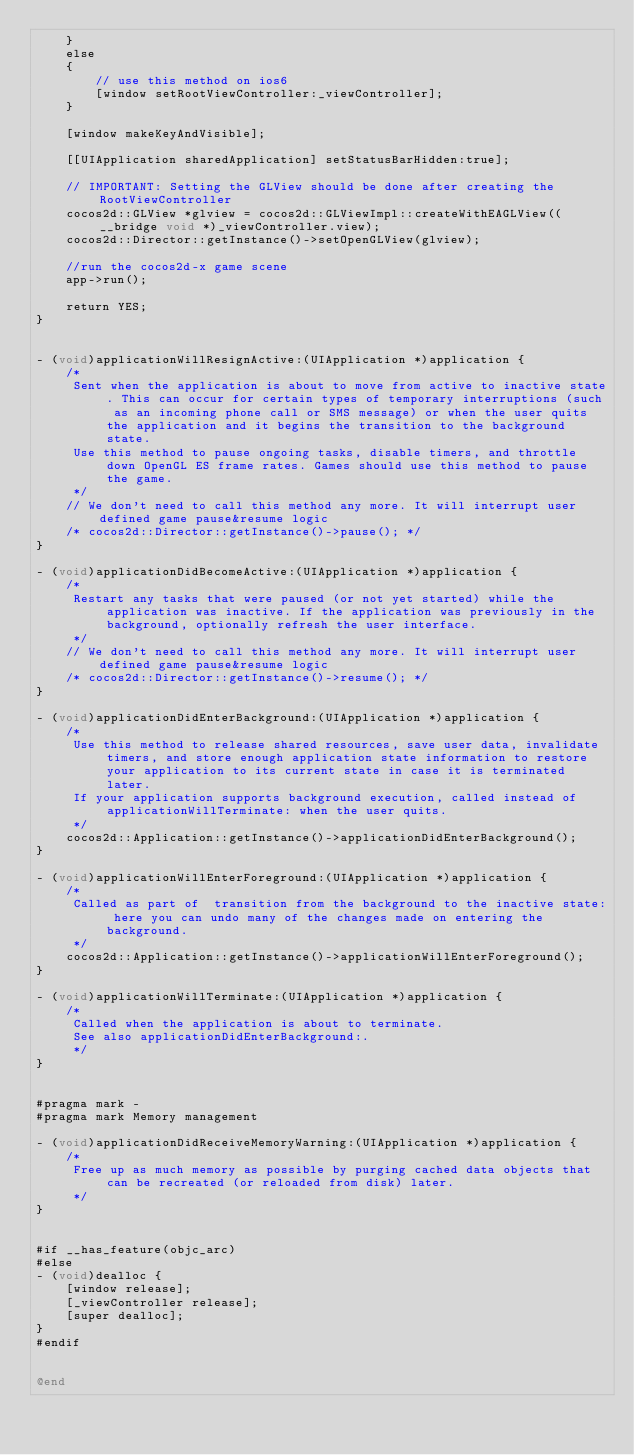<code> <loc_0><loc_0><loc_500><loc_500><_ObjectiveC_>    }
    else
    {
        // use this method on ios6
        [window setRootViewController:_viewController];
    }
    
    [window makeKeyAndVisible];
    
    [[UIApplication sharedApplication] setStatusBarHidden:true];
    
    // IMPORTANT: Setting the GLView should be done after creating the RootViewController
    cocos2d::GLView *glview = cocos2d::GLViewImpl::createWithEAGLView((__bridge void *)_viewController.view);
    cocos2d::Director::getInstance()->setOpenGLView(glview);
    
    //run the cocos2d-x game scene
    app->run();
    
    return YES;
}


- (void)applicationWillResignActive:(UIApplication *)application {
    /*
     Sent when the application is about to move from active to inactive state. This can occur for certain types of temporary interruptions (such as an incoming phone call or SMS message) or when the user quits the application and it begins the transition to the background state.
     Use this method to pause ongoing tasks, disable timers, and throttle down OpenGL ES frame rates. Games should use this method to pause the game.
     */
    // We don't need to call this method any more. It will interrupt user defined game pause&resume logic
    /* cocos2d::Director::getInstance()->pause(); */
}

- (void)applicationDidBecomeActive:(UIApplication *)application {
    /*
     Restart any tasks that were paused (or not yet started) while the application was inactive. If the application was previously in the background, optionally refresh the user interface.
     */
    // We don't need to call this method any more. It will interrupt user defined game pause&resume logic
    /* cocos2d::Director::getInstance()->resume(); */
}

- (void)applicationDidEnterBackground:(UIApplication *)application {
    /*
     Use this method to release shared resources, save user data, invalidate timers, and store enough application state information to restore your application to its current state in case it is terminated later.
     If your application supports background execution, called instead of applicationWillTerminate: when the user quits.
     */
    cocos2d::Application::getInstance()->applicationDidEnterBackground();
}

- (void)applicationWillEnterForeground:(UIApplication *)application {
    /*
     Called as part of  transition from the background to the inactive state: here you can undo many of the changes made on entering the background.
     */
    cocos2d::Application::getInstance()->applicationWillEnterForeground();
}

- (void)applicationWillTerminate:(UIApplication *)application {
    /*
     Called when the application is about to terminate.
     See also applicationDidEnterBackground:.
     */
}


#pragma mark -
#pragma mark Memory management

- (void)applicationDidReceiveMemoryWarning:(UIApplication *)application {
    /*
     Free up as much memory as possible by purging cached data objects that can be recreated (or reloaded from disk) later.
     */
}


#if __has_feature(objc_arc)
#else
- (void)dealloc {
    [window release];
    [_viewController release];
    [super dealloc];
}
#endif


@end

</code> 